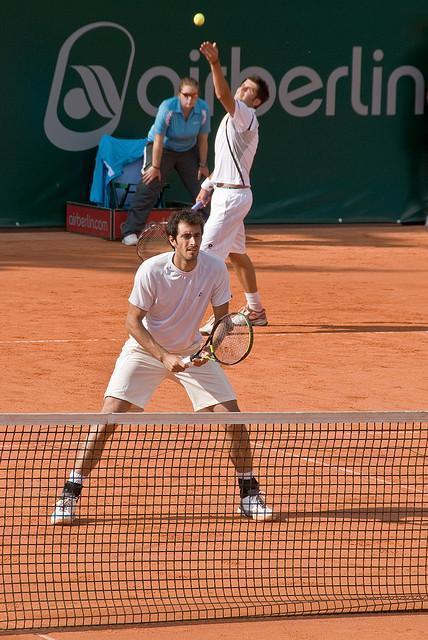How many people are on each team?
Give a very brief answer. 2. How many people can you see?
Give a very brief answer. 3. 